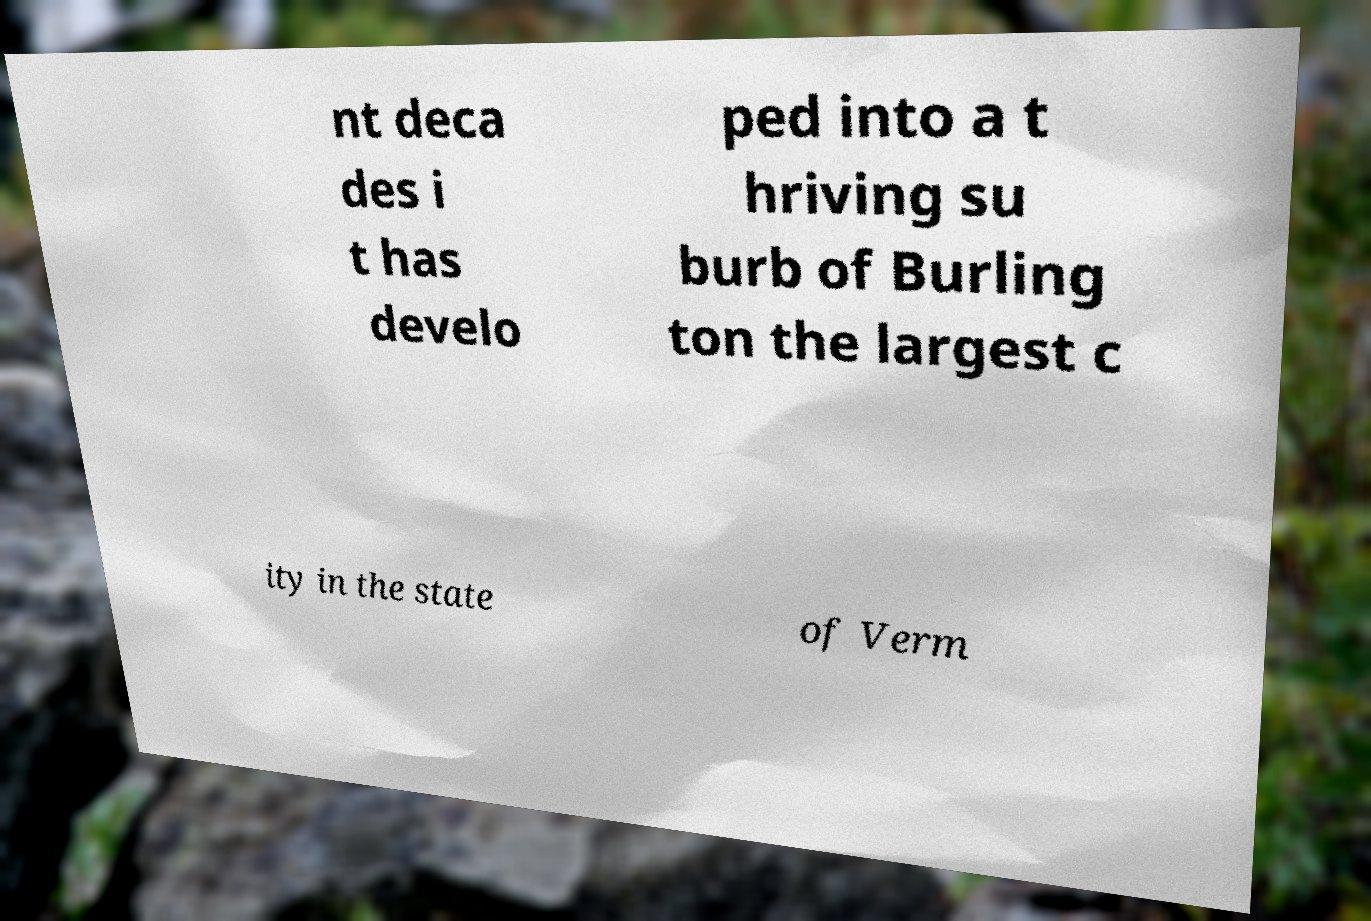What messages or text are displayed in this image? I need them in a readable, typed format. nt deca des i t has develo ped into a t hriving su burb of Burling ton the largest c ity in the state of Verm 